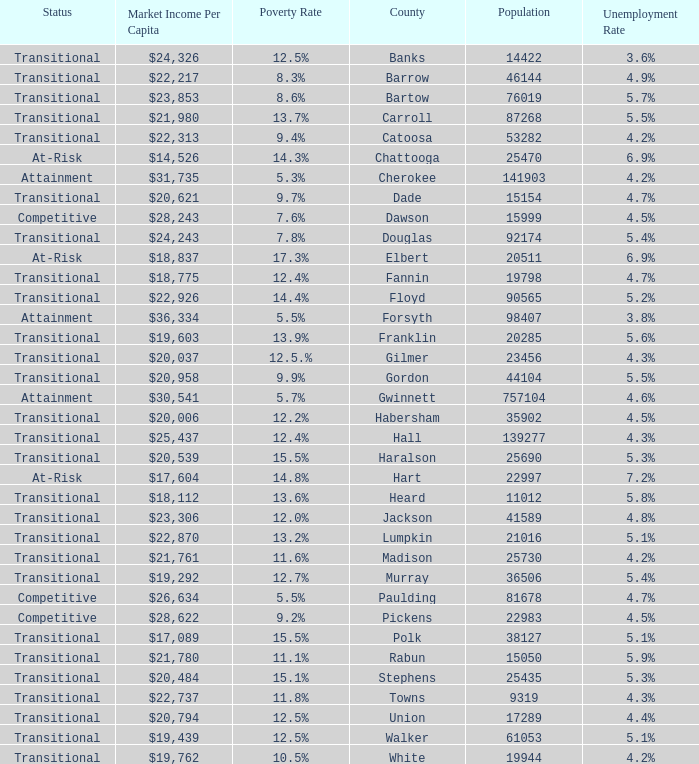What is the status of the county with per capita market income of $24,326? Transitional. 